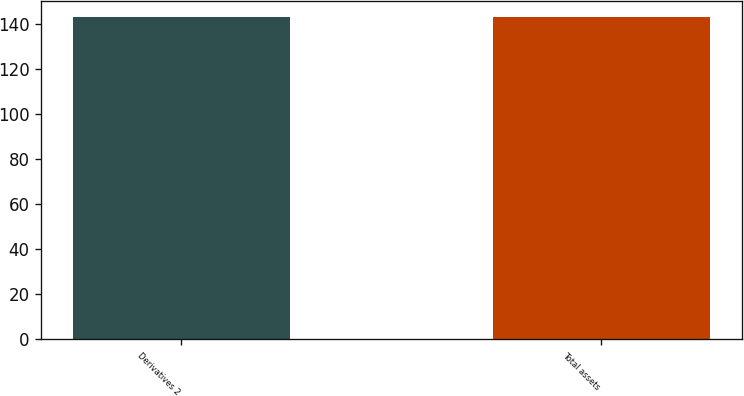Convert chart to OTSL. <chart><loc_0><loc_0><loc_500><loc_500><bar_chart><fcel>Derivatives 2<fcel>Total assets<nl><fcel>143<fcel>143.1<nl></chart> 